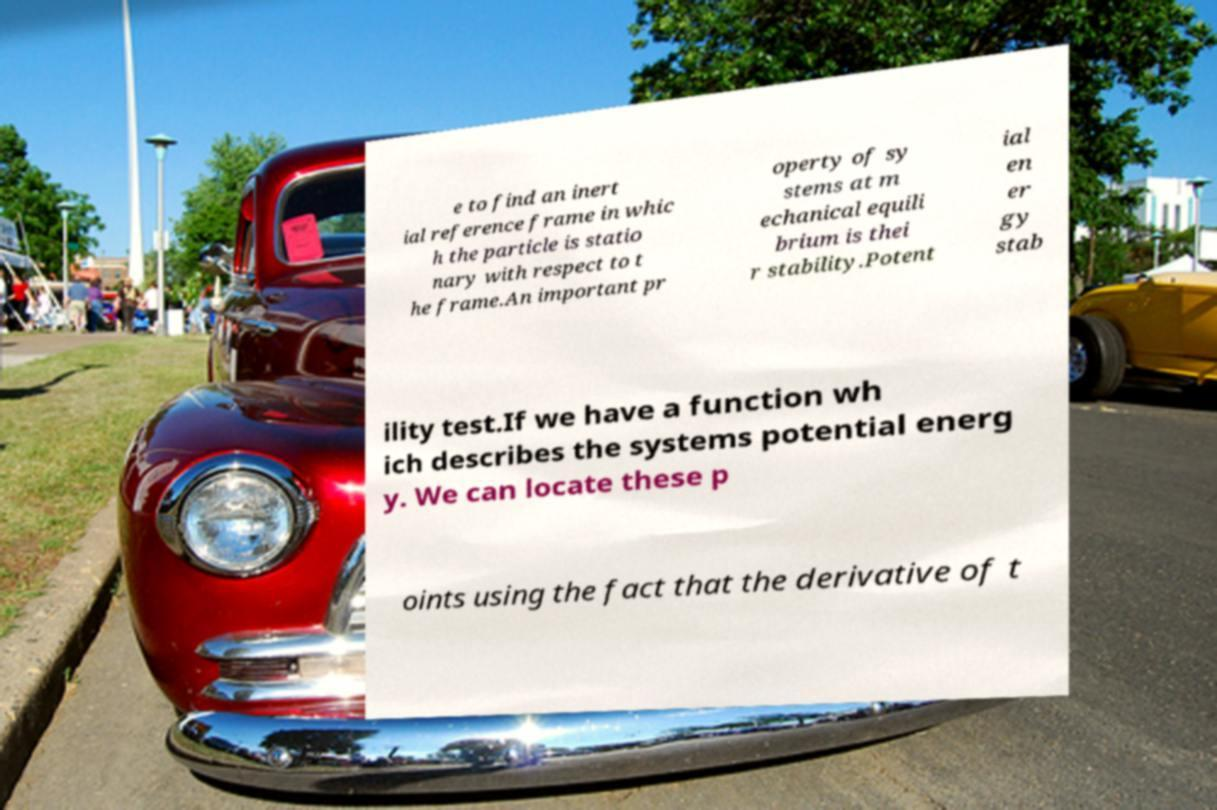There's text embedded in this image that I need extracted. Can you transcribe it verbatim? e to find an inert ial reference frame in whic h the particle is statio nary with respect to t he frame.An important pr operty of sy stems at m echanical equili brium is thei r stability.Potent ial en er gy stab ility test.If we have a function wh ich describes the systems potential energ y. We can locate these p oints using the fact that the derivative of t 